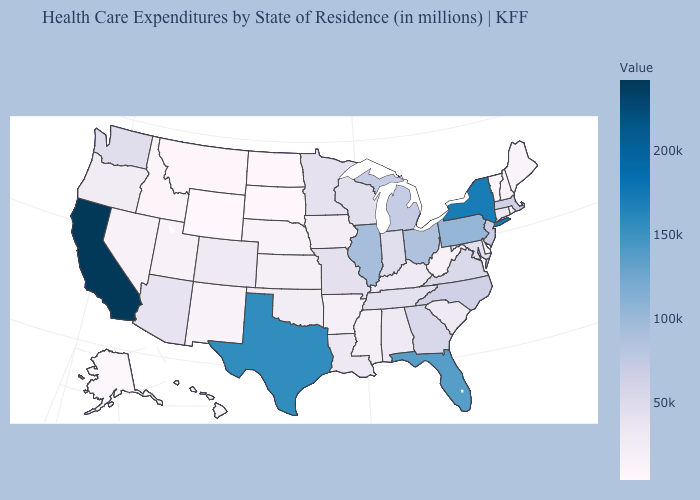Among the states that border Montana , which have the highest value?
Answer briefly. Idaho. Which states hav the highest value in the MidWest?
Short answer required. Illinois. Does Wyoming have the lowest value in the USA?
Answer briefly. Yes. 